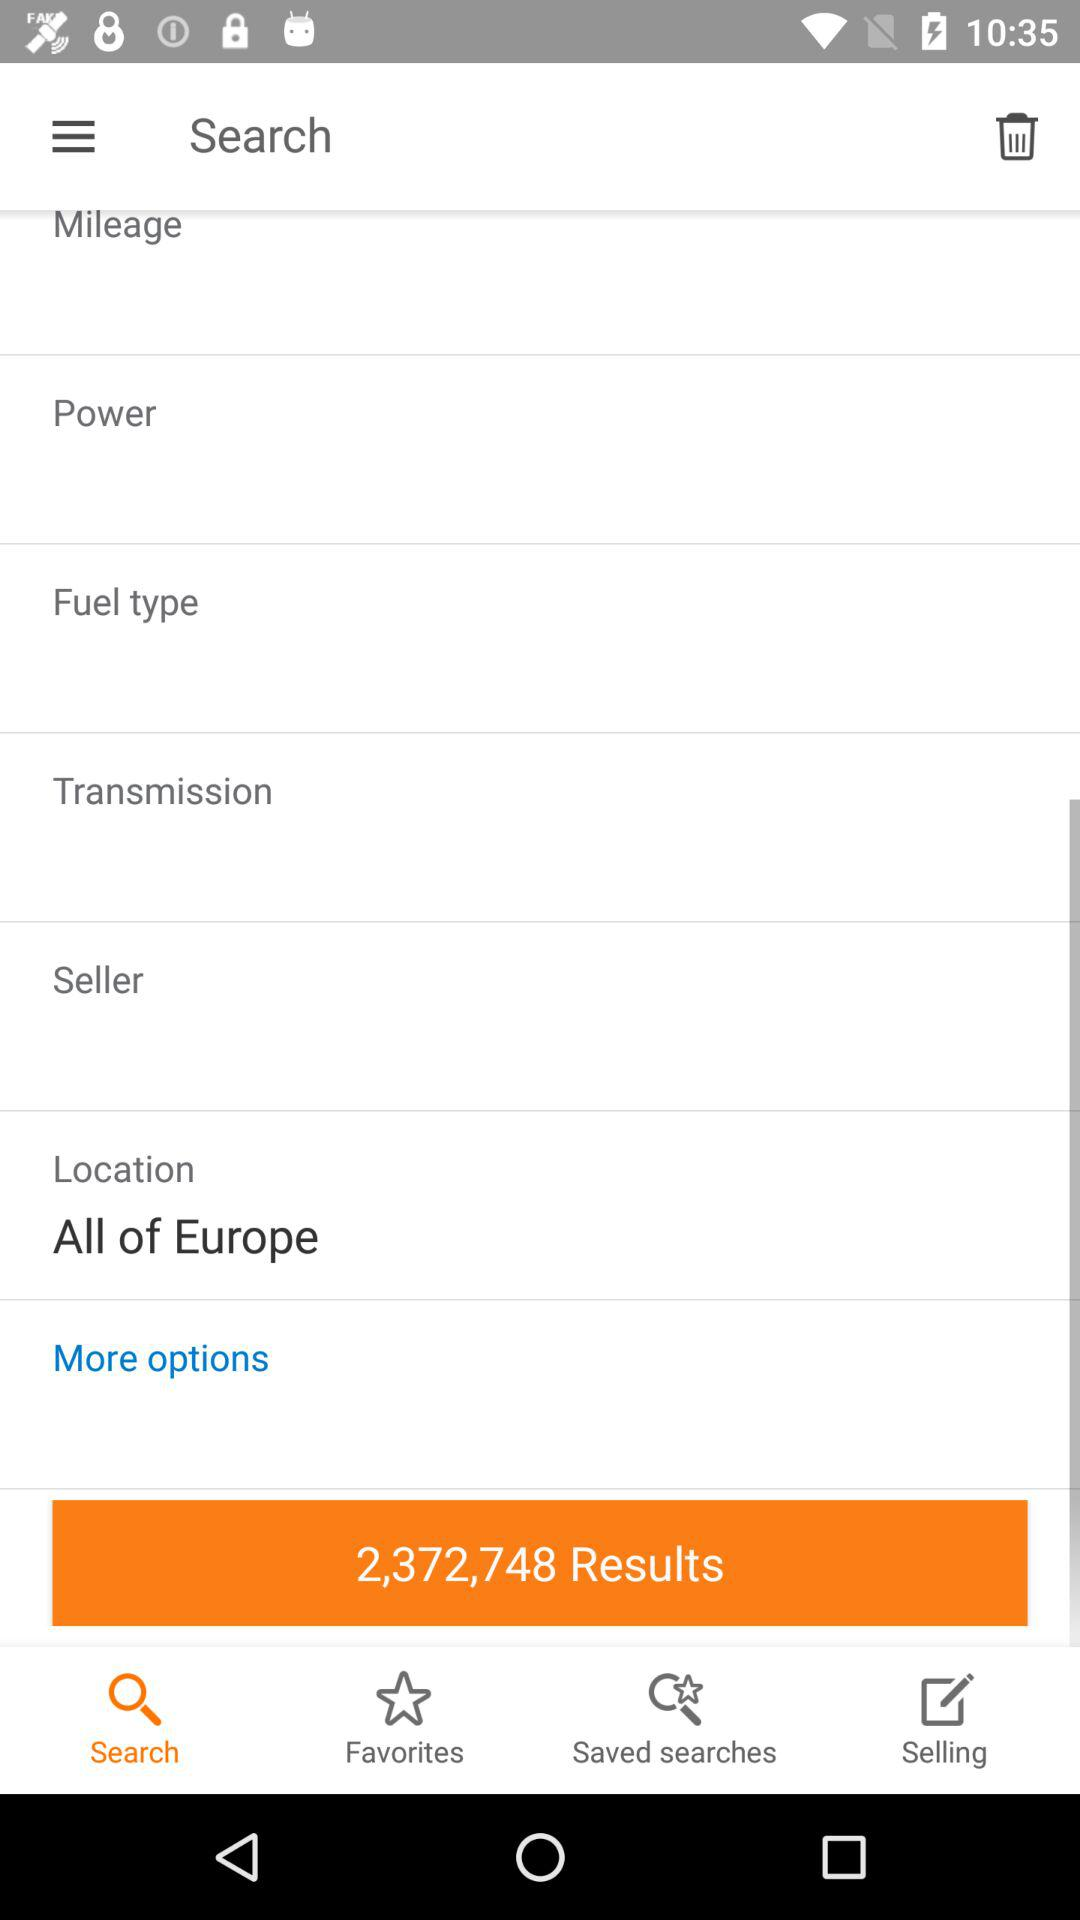How many results are shown on the screen? There are 2,372,748 results shown on the screen. 